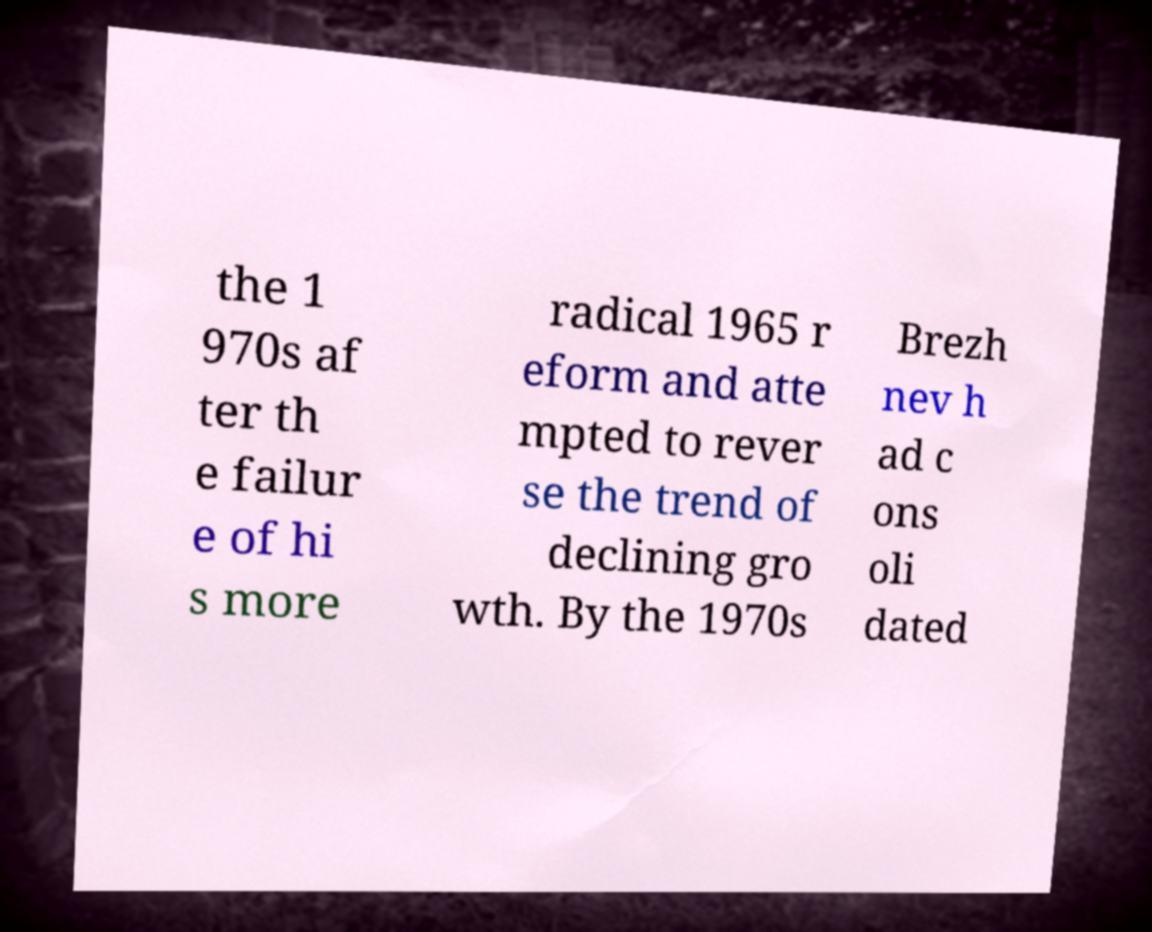Could you extract and type out the text from this image? the 1 970s af ter th e failur e of hi s more radical 1965 r eform and atte mpted to rever se the trend of declining gro wth. By the 1970s Brezh nev h ad c ons oli dated 